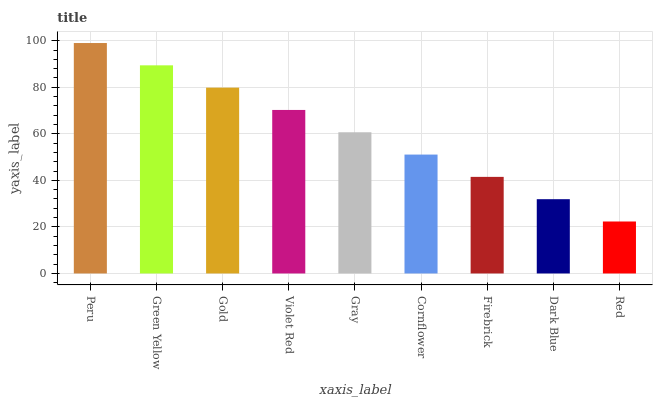Is Red the minimum?
Answer yes or no. Yes. Is Peru the maximum?
Answer yes or no. Yes. Is Green Yellow the minimum?
Answer yes or no. No. Is Green Yellow the maximum?
Answer yes or no. No. Is Peru greater than Green Yellow?
Answer yes or no. Yes. Is Green Yellow less than Peru?
Answer yes or no. Yes. Is Green Yellow greater than Peru?
Answer yes or no. No. Is Peru less than Green Yellow?
Answer yes or no. No. Is Gray the high median?
Answer yes or no. Yes. Is Gray the low median?
Answer yes or no. Yes. Is Firebrick the high median?
Answer yes or no. No. Is Violet Red the low median?
Answer yes or no. No. 